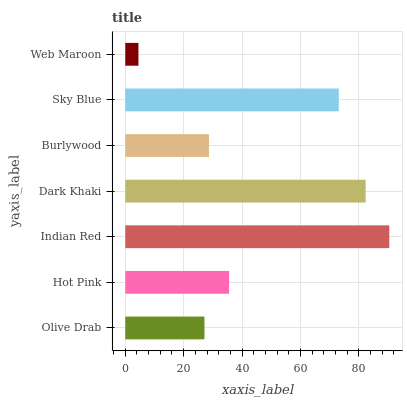Is Web Maroon the minimum?
Answer yes or no. Yes. Is Indian Red the maximum?
Answer yes or no. Yes. Is Hot Pink the minimum?
Answer yes or no. No. Is Hot Pink the maximum?
Answer yes or no. No. Is Hot Pink greater than Olive Drab?
Answer yes or no. Yes. Is Olive Drab less than Hot Pink?
Answer yes or no. Yes. Is Olive Drab greater than Hot Pink?
Answer yes or no. No. Is Hot Pink less than Olive Drab?
Answer yes or no. No. Is Hot Pink the high median?
Answer yes or no. Yes. Is Hot Pink the low median?
Answer yes or no. Yes. Is Indian Red the high median?
Answer yes or no. No. Is Web Maroon the low median?
Answer yes or no. No. 